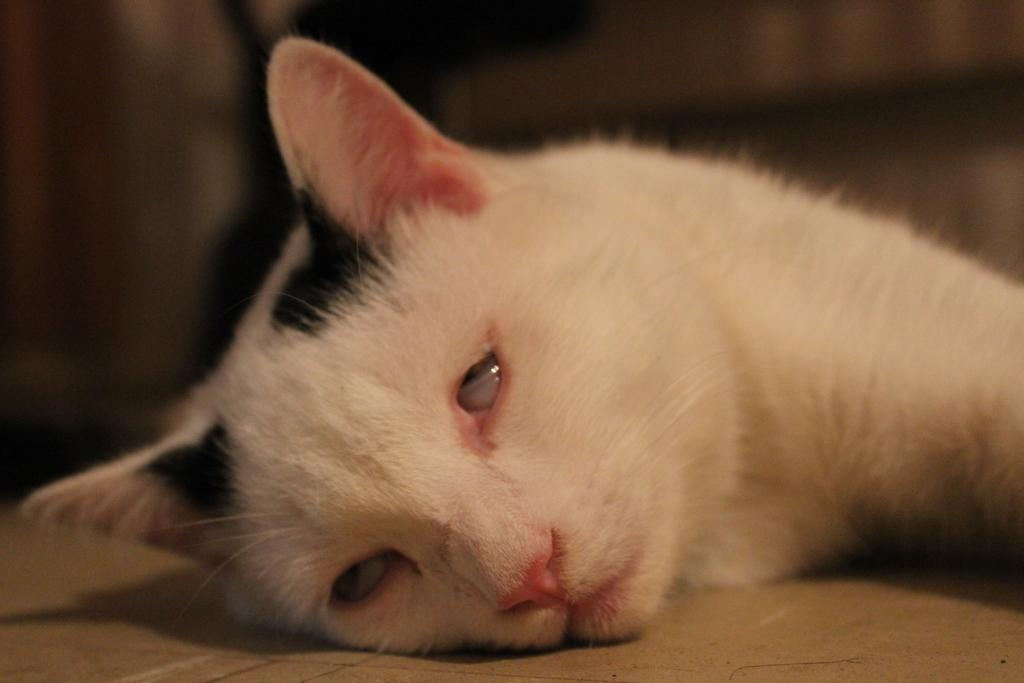What animal is present in the image? There is a cat in the image. What is the cat doing in the image? The cat is lying on a surface. Can you describe the background of the image? The background of the image is blurry. What page is the bird reading in the image? There is no bird or page present in the image; it features a cat lying on a surface. How does the cat stretch in the image? The cat is not stretching in the image; it is lying on a surface. 